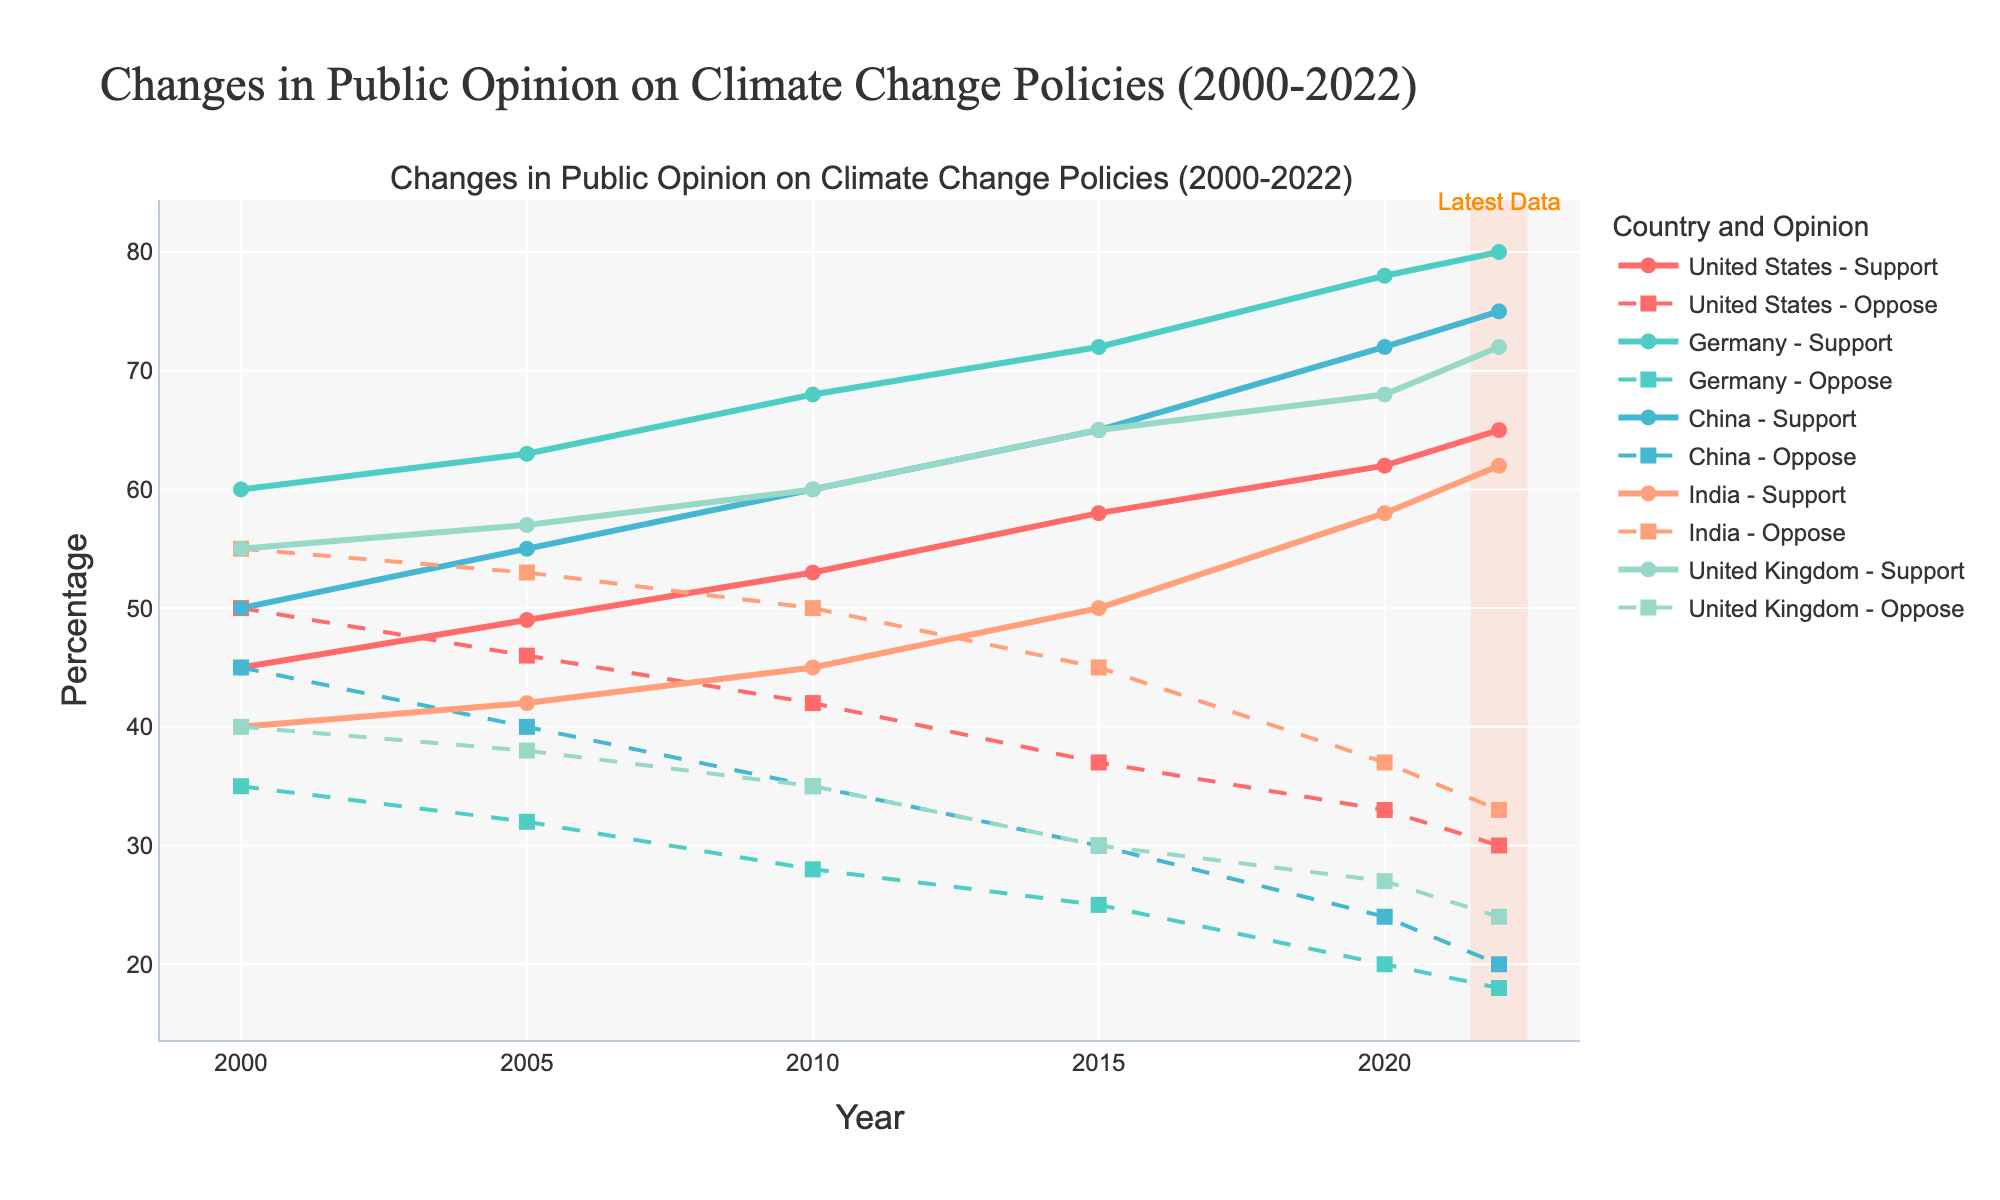what is the color of the line representing Germany - Support? The plot uses different colors for each country. The Support line for Germany is represented in a specific color.
Answer: turquoise Which country shows the highest Support Percentage in 2022? By examining the Support Percentage lines for the year 2022, we can identify which country has the highest percentage.
Answer: Germany Between 2000 and 2022, which country had the steepest increase in Support Percentage? To determine this, compare the start and end points of the Support Percentage lines for each country and calculate the rise over the time period.
Answer: United States What is the difference in Support Percentage between China and India in 2015? By looking at the Support Percentage lines for both China and India and finding their values in 2015, we can calculate the difference.
Answer: 15% Which country had the least change in Oppose Percentage from 2000 to 2022? By calculating the difference in Oppose Percentage between 2000 and 2022 for each country, we can identify the country with the least change.
Answer: United States Did any country's Support Percentage ever decline between any two consecutive years? By examining the lines for each country, see if there is any downward trend between two consecutive years in the Support Percentage.
Answer: No Which country's Oppose Percentage was the highest in 2020? Look for the highest point on the Oppose Percentage lines for the year 2020 to identify the country.
Answer: United States What is the average Support Percentage for Germany from 2000 to 2022? Calculate the mean of the Support Percentages for Germany across the given years: (60 + 63 + 68 + 72 + 78 + 80) / 6.
Answer: 70.2% During which year did public opinion in the United States see the most significant decrease in Oppose Percentage? Find the year-to-year decrease in Oppose Percentage for the United States and identify the year with the highest drop.
Answer: 2010 Which country had a Support Percentage closest to 50% in 2000? Examine the Support Percentages for all countries in the year 2000 and see which one is nearest to 50%.
Answer: China 